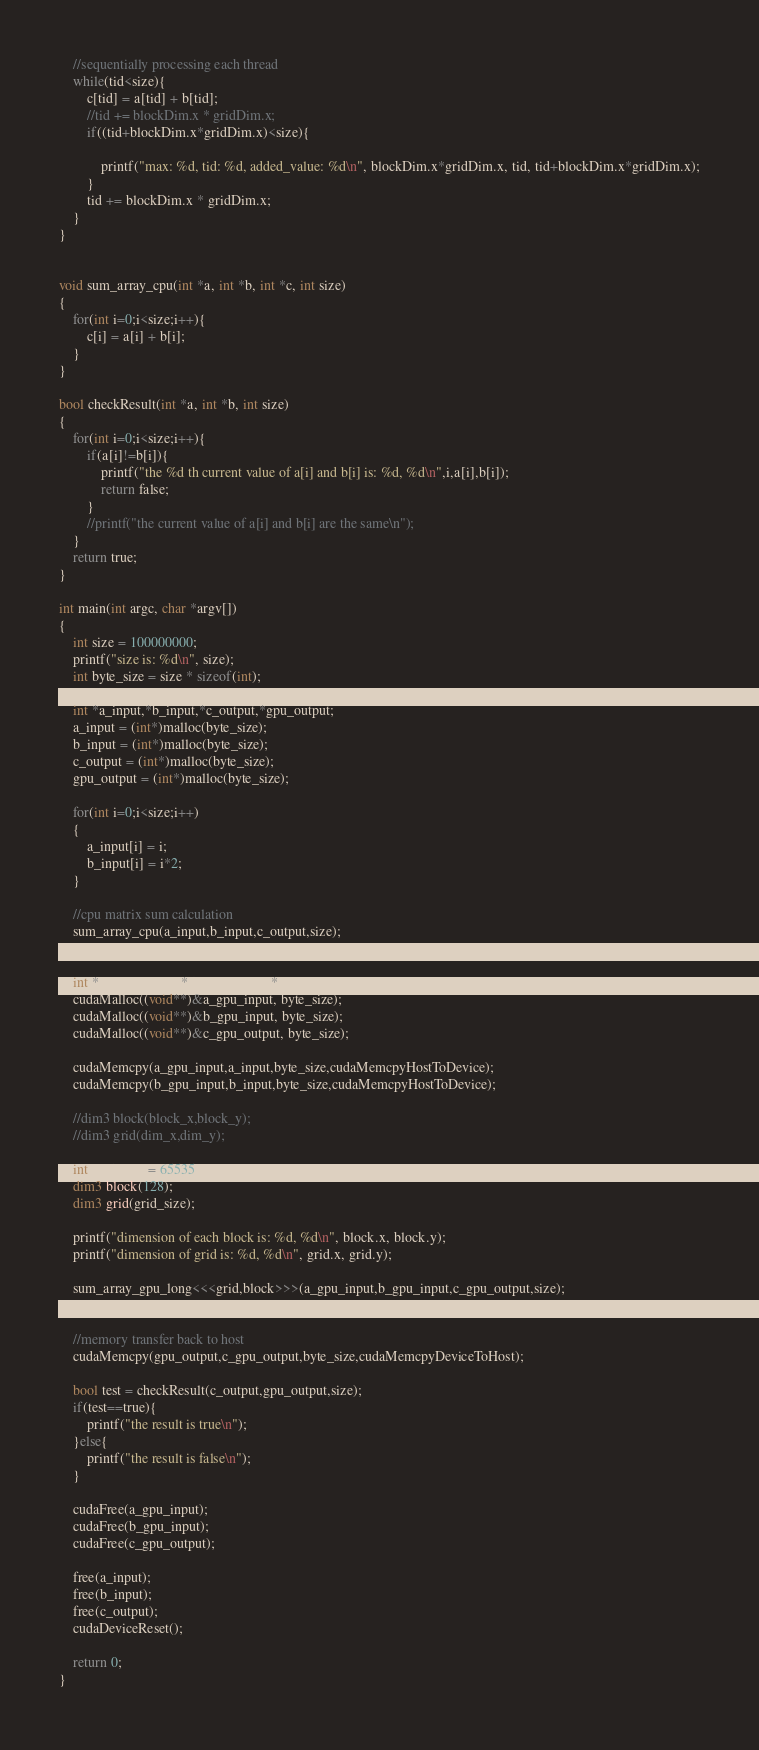<code> <loc_0><loc_0><loc_500><loc_500><_Cuda_>    //sequentially processing each thread
    while(tid<size){
        c[tid] = a[tid] + b[tid];
        //tid += blockDim.x * gridDim.x;
        if((tid+blockDim.x*gridDim.x)<size){

            printf("max: %d, tid: %d, added_value: %d\n", blockDim.x*gridDim.x, tid, tid+blockDim.x*gridDim.x);
        }
        tid += blockDim.x * gridDim.x;
    }
}


void sum_array_cpu(int *a, int *b, int *c, int size)
{
    for(int i=0;i<size;i++){
        c[i] = a[i] + b[i];
    }
}

bool checkResult(int *a, int *b, int size)
{
    for(int i=0;i<size;i++){
        if(a[i]!=b[i]){
            printf("the %d th current value of a[i] and b[i] is: %d, %d\n",i,a[i],b[i]);
            return false;
        }
        //printf("the current value of a[i] and b[i] are the same\n");
    }
    return true;
}

int main(int argc, char *argv[])
{	
    int size = 100000000;
    printf("size is: %d\n", size);
    int byte_size = size * sizeof(int);

    int *a_input,*b_input,*c_output,*gpu_output;
    a_input = (int*)malloc(byte_size);
    b_input = (int*)malloc(byte_size);
    c_output = (int*)malloc(byte_size);
    gpu_output = (int*)malloc(byte_size);

    for(int i=0;i<size;i++)
    {
        a_input[i] = i;
        b_input[i] = i*2;
    }
    
    //cpu matrix sum calculation
    sum_array_cpu(a_input,b_input,c_output,size);


    int * a_gpu_input, * b_gpu_input, *c_gpu_output;
    cudaMalloc((void**)&a_gpu_input, byte_size);
    cudaMalloc((void**)&b_gpu_input, byte_size);
    cudaMalloc((void**)&c_gpu_output, byte_size);

    cudaMemcpy(a_gpu_input,a_input,byte_size,cudaMemcpyHostToDevice);
    cudaMemcpy(b_gpu_input,b_input,byte_size,cudaMemcpyHostToDevice);

    //dim3 block(block_x,block_y);
    //dim3 grid(dim_x,dim_y);
    
    int grid_size = 65535;
    dim3 block(128);
    dim3 grid(grid_size);

    printf("dimension of each block is: %d, %d\n", block.x, block.y);
    printf("dimension of grid is: %d, %d\n", grid.x, grid.y);
    
    sum_array_gpu_long<<<grid,block>>>(a_gpu_input,b_gpu_input,c_gpu_output,size);
    cudaDeviceSynchronize();
    
    //memory transfer back to host
    cudaMemcpy(gpu_output,c_gpu_output,byte_size,cudaMemcpyDeviceToHost);

    bool test = checkResult(c_output,gpu_output,size);
    if(test==true){
        printf("the result is true\n");
    }else{
        printf("the result is false\n");
    }

    cudaFree(a_gpu_input);
    cudaFree(b_gpu_input);
    cudaFree(c_gpu_output);
    
    free(a_input);
    free(b_input);
	free(c_output);
    cudaDeviceReset();
	
    return 0;
}
</code> 